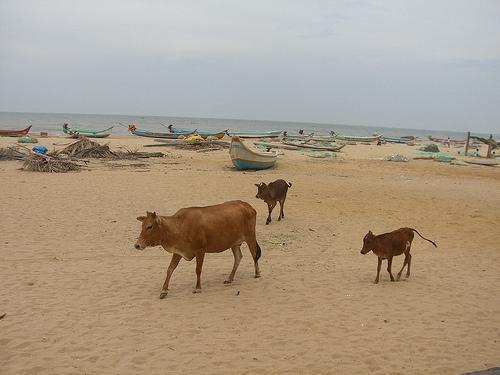How many cows are in the photo?
Give a very brief answer. 3. 